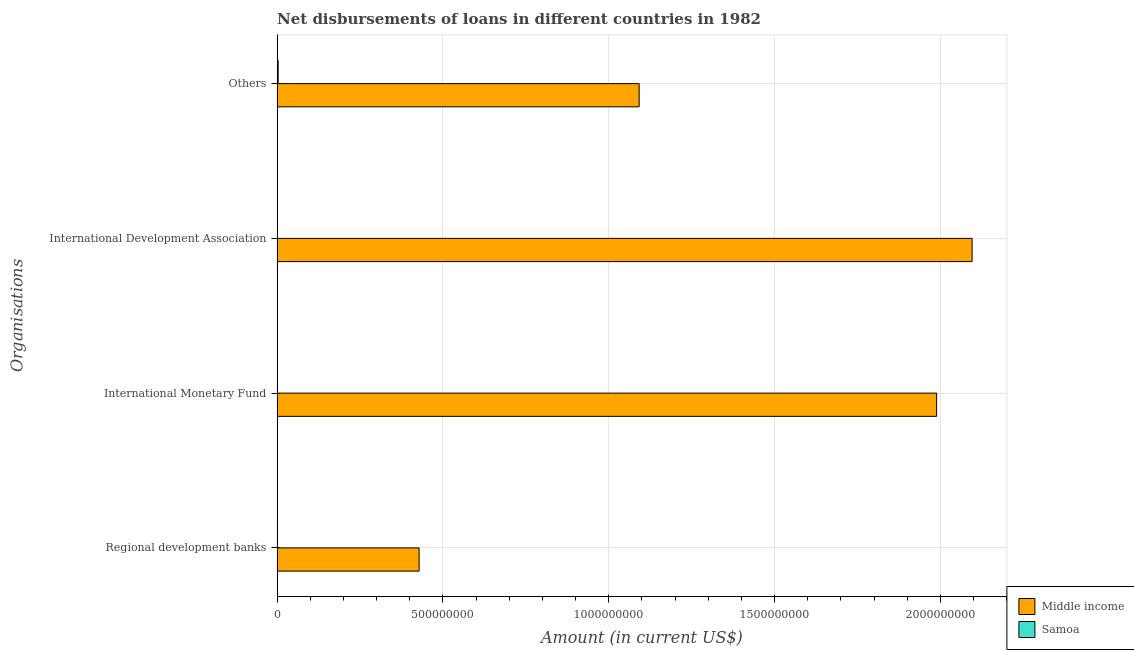How many different coloured bars are there?
Make the answer very short. 2. Are the number of bars on each tick of the Y-axis equal?
Your answer should be compact. No. How many bars are there on the 2nd tick from the bottom?
Your answer should be compact. 1. What is the label of the 1st group of bars from the top?
Your answer should be compact. Others. What is the amount of loan disimbursed by regional development banks in Samoa?
Provide a succinct answer. 1.19e+06. Across all countries, what is the maximum amount of loan disimbursed by regional development banks?
Your answer should be very brief. 4.28e+08. Across all countries, what is the minimum amount of loan disimbursed by international development association?
Keep it short and to the point. 1.09e+06. What is the total amount of loan disimbursed by international monetary fund in the graph?
Provide a short and direct response. 1.99e+09. What is the difference between the amount of loan disimbursed by international development association in Samoa and that in Middle income?
Keep it short and to the point. -2.09e+09. What is the difference between the amount of loan disimbursed by international development association in Samoa and the amount of loan disimbursed by regional development banks in Middle income?
Make the answer very short. -4.27e+08. What is the average amount of loan disimbursed by other organisations per country?
Ensure brevity in your answer.  5.47e+08. What is the difference between the amount of loan disimbursed by international monetary fund and amount of loan disimbursed by regional development banks in Middle income?
Ensure brevity in your answer.  1.56e+09. In how many countries, is the amount of loan disimbursed by international development association greater than 800000000 US$?
Provide a short and direct response. 1. What is the ratio of the amount of loan disimbursed by international development association in Middle income to that in Samoa?
Offer a terse response. 1919.02. What is the difference between the highest and the second highest amount of loan disimbursed by other organisations?
Your answer should be very brief. 1.09e+09. What is the difference between the highest and the lowest amount of loan disimbursed by regional development banks?
Offer a terse response. 4.27e+08. Is the sum of the amount of loan disimbursed by international development association in Samoa and Middle income greater than the maximum amount of loan disimbursed by international monetary fund across all countries?
Your response must be concise. Yes. Are all the bars in the graph horizontal?
Give a very brief answer. Yes. How many countries are there in the graph?
Ensure brevity in your answer.  2. What is the difference between two consecutive major ticks on the X-axis?
Provide a short and direct response. 5.00e+08. Are the values on the major ticks of X-axis written in scientific E-notation?
Offer a terse response. No. How many legend labels are there?
Give a very brief answer. 2. What is the title of the graph?
Ensure brevity in your answer.  Net disbursements of loans in different countries in 1982. Does "Sierra Leone" appear as one of the legend labels in the graph?
Your answer should be very brief. No. What is the label or title of the X-axis?
Your answer should be compact. Amount (in current US$). What is the label or title of the Y-axis?
Keep it short and to the point. Organisations. What is the Amount (in current US$) of Middle income in Regional development banks?
Provide a short and direct response. 4.28e+08. What is the Amount (in current US$) in Samoa in Regional development banks?
Keep it short and to the point. 1.19e+06. What is the Amount (in current US$) in Middle income in International Monetary Fund?
Give a very brief answer. 1.99e+09. What is the Amount (in current US$) in Samoa in International Monetary Fund?
Your answer should be compact. 0. What is the Amount (in current US$) of Middle income in International Development Association?
Your answer should be very brief. 2.10e+09. What is the Amount (in current US$) in Samoa in International Development Association?
Provide a succinct answer. 1.09e+06. What is the Amount (in current US$) of Middle income in Others?
Offer a very short reply. 1.09e+09. What is the Amount (in current US$) of Samoa in Others?
Provide a succinct answer. 3.11e+06. Across all Organisations, what is the maximum Amount (in current US$) of Middle income?
Your answer should be compact. 2.10e+09. Across all Organisations, what is the maximum Amount (in current US$) of Samoa?
Give a very brief answer. 3.11e+06. Across all Organisations, what is the minimum Amount (in current US$) in Middle income?
Your answer should be very brief. 4.28e+08. Across all Organisations, what is the minimum Amount (in current US$) of Samoa?
Make the answer very short. 0. What is the total Amount (in current US$) of Middle income in the graph?
Give a very brief answer. 5.60e+09. What is the total Amount (in current US$) in Samoa in the graph?
Provide a succinct answer. 5.39e+06. What is the difference between the Amount (in current US$) in Middle income in Regional development banks and that in International Monetary Fund?
Your response must be concise. -1.56e+09. What is the difference between the Amount (in current US$) in Middle income in Regional development banks and that in International Development Association?
Offer a very short reply. -1.67e+09. What is the difference between the Amount (in current US$) in Samoa in Regional development banks and that in International Development Association?
Make the answer very short. 1.00e+05. What is the difference between the Amount (in current US$) in Middle income in Regional development banks and that in Others?
Your answer should be very brief. -6.64e+08. What is the difference between the Amount (in current US$) in Samoa in Regional development banks and that in Others?
Your response must be concise. -1.92e+06. What is the difference between the Amount (in current US$) in Middle income in International Monetary Fund and that in International Development Association?
Your response must be concise. -1.07e+08. What is the difference between the Amount (in current US$) of Middle income in International Monetary Fund and that in Others?
Your answer should be compact. 8.97e+08. What is the difference between the Amount (in current US$) in Middle income in International Development Association and that in Others?
Your answer should be compact. 1.00e+09. What is the difference between the Amount (in current US$) of Samoa in International Development Association and that in Others?
Your answer should be very brief. -2.02e+06. What is the difference between the Amount (in current US$) of Middle income in Regional development banks and the Amount (in current US$) of Samoa in International Development Association?
Ensure brevity in your answer.  4.27e+08. What is the difference between the Amount (in current US$) of Middle income in Regional development banks and the Amount (in current US$) of Samoa in Others?
Make the answer very short. 4.25e+08. What is the difference between the Amount (in current US$) of Middle income in International Monetary Fund and the Amount (in current US$) of Samoa in International Development Association?
Provide a succinct answer. 1.99e+09. What is the difference between the Amount (in current US$) in Middle income in International Monetary Fund and the Amount (in current US$) in Samoa in Others?
Your answer should be very brief. 1.99e+09. What is the difference between the Amount (in current US$) of Middle income in International Development Association and the Amount (in current US$) of Samoa in Others?
Your response must be concise. 2.09e+09. What is the average Amount (in current US$) in Middle income per Organisations?
Provide a short and direct response. 1.40e+09. What is the average Amount (in current US$) of Samoa per Organisations?
Offer a terse response. 1.35e+06. What is the difference between the Amount (in current US$) in Middle income and Amount (in current US$) in Samoa in Regional development banks?
Provide a short and direct response. 4.27e+08. What is the difference between the Amount (in current US$) in Middle income and Amount (in current US$) in Samoa in International Development Association?
Offer a terse response. 2.09e+09. What is the difference between the Amount (in current US$) of Middle income and Amount (in current US$) of Samoa in Others?
Keep it short and to the point. 1.09e+09. What is the ratio of the Amount (in current US$) in Middle income in Regional development banks to that in International Monetary Fund?
Make the answer very short. 0.22. What is the ratio of the Amount (in current US$) of Middle income in Regional development banks to that in International Development Association?
Your answer should be very brief. 0.2. What is the ratio of the Amount (in current US$) of Samoa in Regional development banks to that in International Development Association?
Offer a very short reply. 1.09. What is the ratio of the Amount (in current US$) in Middle income in Regional development banks to that in Others?
Offer a terse response. 0.39. What is the ratio of the Amount (in current US$) of Samoa in Regional development banks to that in Others?
Make the answer very short. 0.38. What is the ratio of the Amount (in current US$) of Middle income in International Monetary Fund to that in International Development Association?
Give a very brief answer. 0.95. What is the ratio of the Amount (in current US$) in Middle income in International Monetary Fund to that in Others?
Make the answer very short. 1.82. What is the ratio of the Amount (in current US$) in Middle income in International Development Association to that in Others?
Offer a terse response. 1.92. What is the ratio of the Amount (in current US$) in Samoa in International Development Association to that in Others?
Provide a succinct answer. 0.35. What is the difference between the highest and the second highest Amount (in current US$) of Middle income?
Offer a very short reply. 1.07e+08. What is the difference between the highest and the second highest Amount (in current US$) of Samoa?
Offer a terse response. 1.92e+06. What is the difference between the highest and the lowest Amount (in current US$) of Middle income?
Offer a very short reply. 1.67e+09. What is the difference between the highest and the lowest Amount (in current US$) of Samoa?
Give a very brief answer. 3.11e+06. 